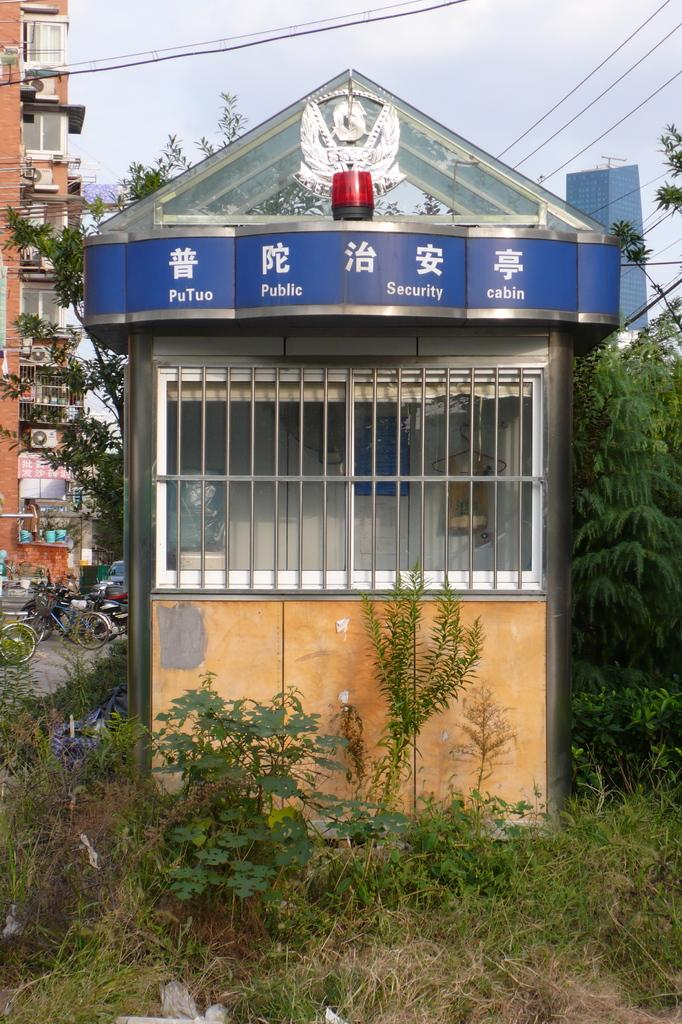What type of structure is present in the image? There is a booth in the image. What type of vegetation can be seen in the image? There are plants and trees in the image. What type of man-made structures are visible in the image? There are buildings in the image. What type of infrastructure is visible in the image? Electric wires are visible in the image. What type of cast is performing in the image? There is no cast performing in the image; it does not depict a performance or show. 